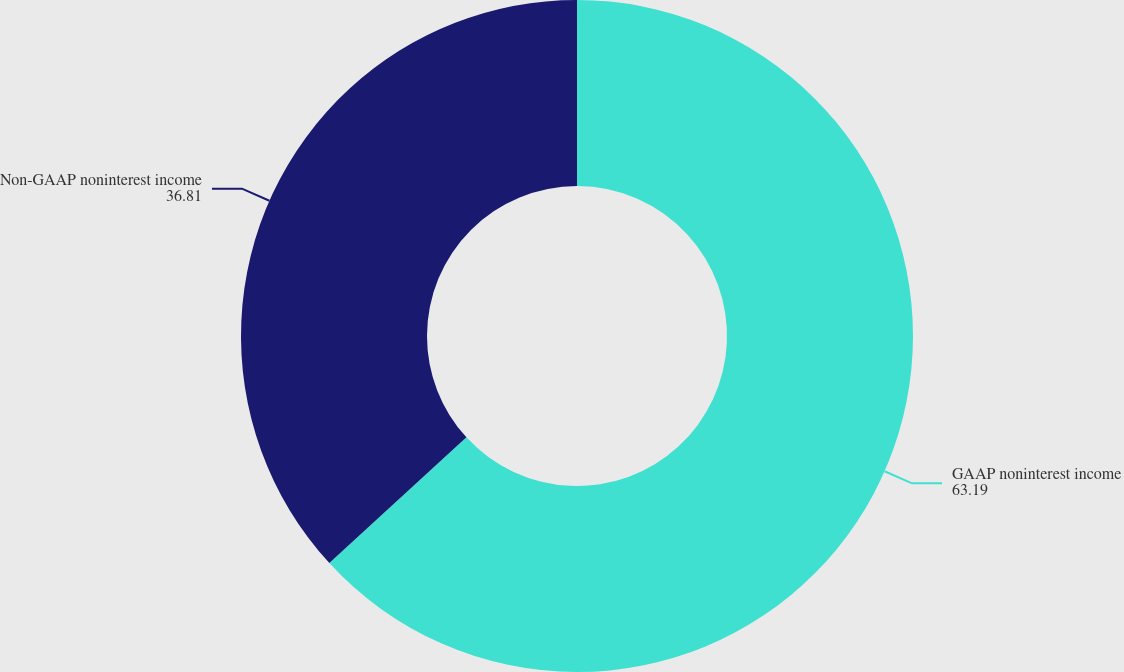Convert chart to OTSL. <chart><loc_0><loc_0><loc_500><loc_500><pie_chart><fcel>GAAP noninterest income<fcel>Non-GAAP noninterest income<nl><fcel>63.19%<fcel>36.81%<nl></chart> 